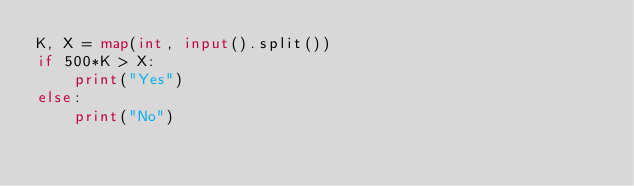Convert code to text. <code><loc_0><loc_0><loc_500><loc_500><_Python_>K, X = map(int, input().split())
if 500*K > X:
    print("Yes")
else:
    print("No")
</code> 